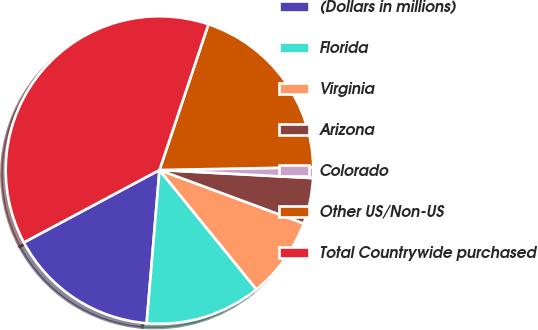Convert chart to OTSL. <chart><loc_0><loc_0><loc_500><loc_500><pie_chart><fcel>(Dollars in millions)<fcel>Florida<fcel>Virginia<fcel>Arizona<fcel>Colorado<fcel>Other US/Non-US<fcel>Total Countrywide purchased<nl><fcel>15.86%<fcel>12.18%<fcel>8.5%<fcel>4.81%<fcel>1.13%<fcel>19.55%<fcel>37.96%<nl></chart> 